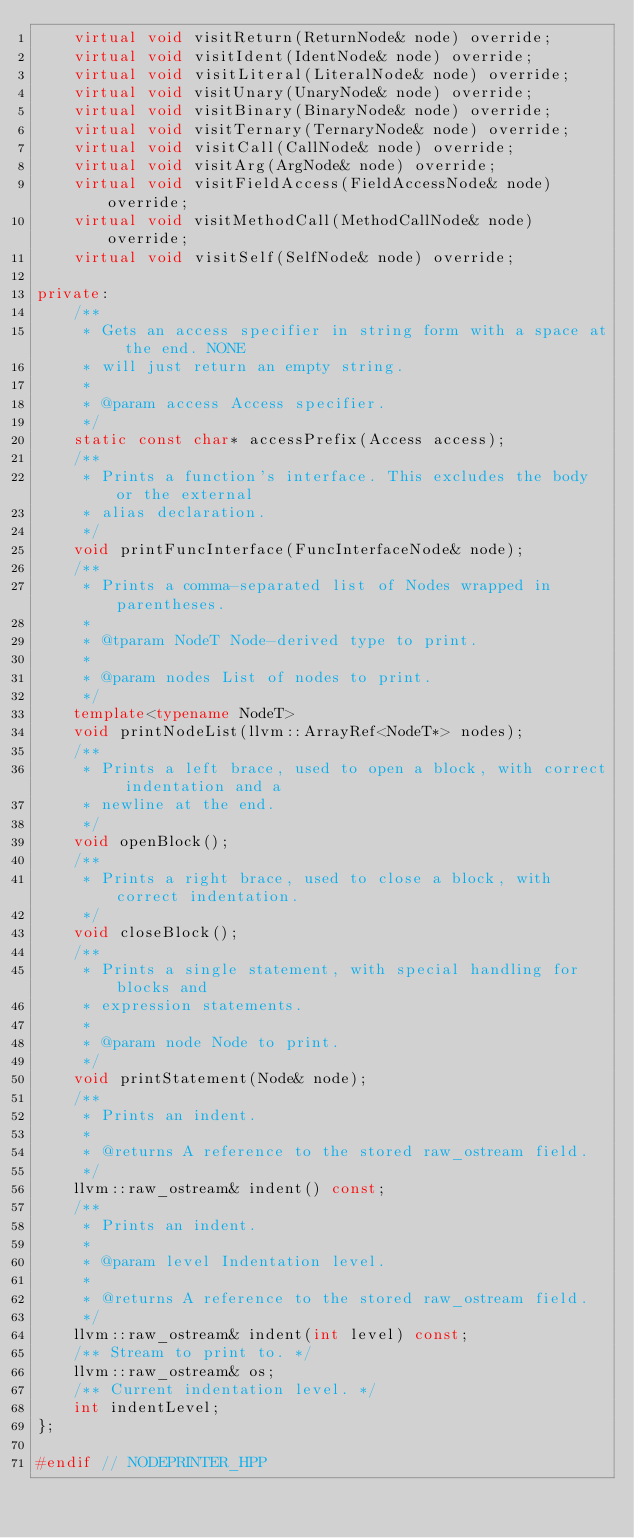<code> <loc_0><loc_0><loc_500><loc_500><_C++_>    virtual void visitReturn(ReturnNode& node) override;
    virtual void visitIdent(IdentNode& node) override;
    virtual void visitLiteral(LiteralNode& node) override;
    virtual void visitUnary(UnaryNode& node) override;
    virtual void visitBinary(BinaryNode& node) override;
    virtual void visitTernary(TernaryNode& node) override;
    virtual void visitCall(CallNode& node) override;
    virtual void visitArg(ArgNode& node) override;
    virtual void visitFieldAccess(FieldAccessNode& node) override;
    virtual void visitMethodCall(MethodCallNode& node) override;
    virtual void visitSelf(SelfNode& node) override;

private:
    /**
     * Gets an access specifier in string form with a space at the end. NONE
     * will just return an empty string.
     *
     * @param access Access specifier.
     */
    static const char* accessPrefix(Access access);
    /**
     * Prints a function's interface. This excludes the body or the external
     * alias declaration.
     */
    void printFuncInterface(FuncInterfaceNode& node);
    /**
     * Prints a comma-separated list of Nodes wrapped in parentheses.
     *
     * @tparam NodeT Node-derived type to print.
     *
     * @param nodes List of nodes to print.
     */
    template<typename NodeT>
    void printNodeList(llvm::ArrayRef<NodeT*> nodes);
    /**
     * Prints a left brace, used to open a block, with correct indentation and a
     * newline at the end.
     */
    void openBlock();
    /**
     * Prints a right brace, used to close a block, with correct indentation.
     */
    void closeBlock();
    /**
     * Prints a single statement, with special handling for blocks and
     * expression statements.
     *
     * @param node Node to print.
     */
    void printStatement(Node& node);
    /**
     * Prints an indent.
     *
     * @returns A reference to the stored raw_ostream field.
     */
    llvm::raw_ostream& indent() const;
    /**
     * Prints an indent.
     *
     * @param level Indentation level.
     *
     * @returns A reference to the stored raw_ostream field.
     */
    llvm::raw_ostream& indent(int level) const;
    /** Stream to print to. */
    llvm::raw_ostream& os;
    /** Current indentation level. */
    int indentLevel;
};

#endif // NODEPRINTER_HPP
</code> 